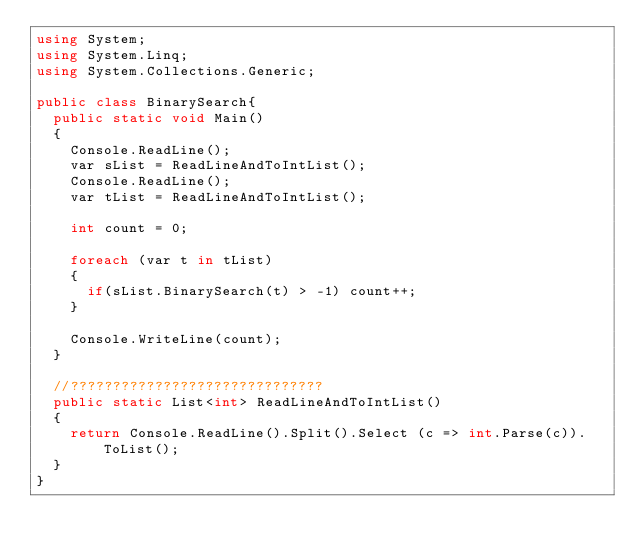<code> <loc_0><loc_0><loc_500><loc_500><_C#_>using System;
using System.Linq;
using System.Collections.Generic;

public class BinarySearch{
	public static void Main()
	{
		Console.ReadLine();
		var sList = ReadLineAndToIntList();
		Console.ReadLine();
		var tList = ReadLineAndToIntList();
	
		int count = 0;
	
		foreach (var t in tList)
		{
			if(sList.BinarySearch(t) > -1) count++;
		}
		
		Console.WriteLine(count);
	}
	
	//??????????????????????????????
	public static List<int> ReadLineAndToIntList()
	{
		return Console.ReadLine().Split().Select (c => int.Parse(c)).ToList();
	}
}</code> 